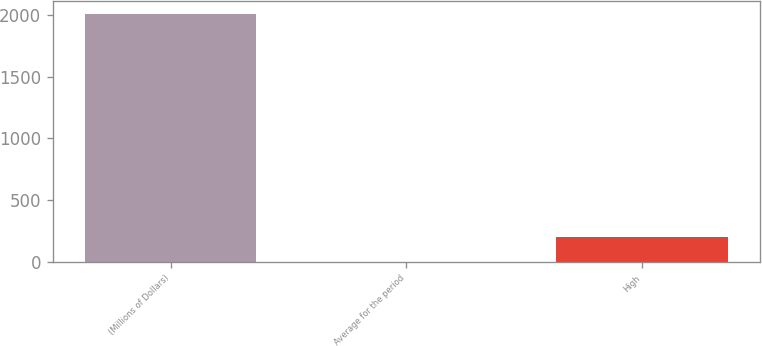Convert chart. <chart><loc_0><loc_0><loc_500><loc_500><bar_chart><fcel>(Millions of Dollars)<fcel>Average for the period<fcel>High<nl><fcel>2012<fcel>1<fcel>202.1<nl></chart> 